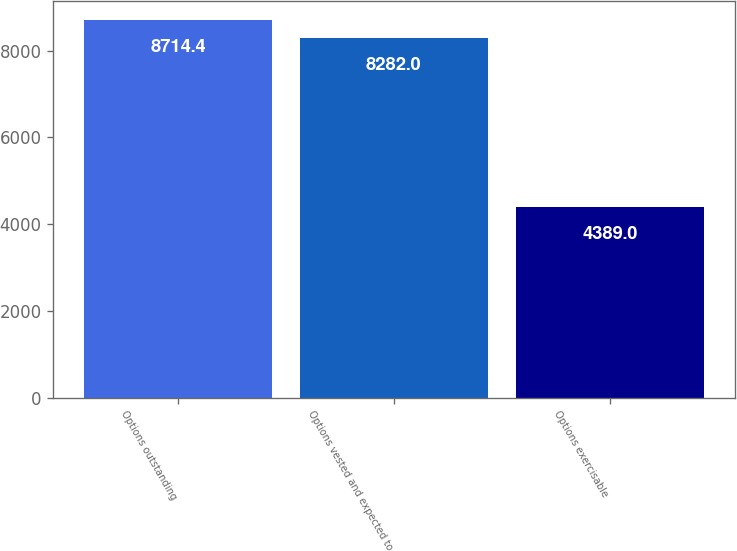Convert chart. <chart><loc_0><loc_0><loc_500><loc_500><bar_chart><fcel>Options outstanding<fcel>Options vested and expected to<fcel>Options exercisable<nl><fcel>8714.4<fcel>8282<fcel>4389<nl></chart> 